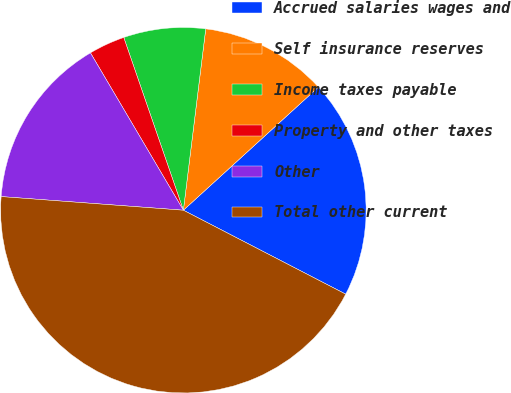<chart> <loc_0><loc_0><loc_500><loc_500><pie_chart><fcel>Accrued salaries wages and<fcel>Self insurance reserves<fcel>Income taxes payable<fcel>Property and other taxes<fcel>Other<fcel>Total other current<nl><fcel>19.36%<fcel>11.28%<fcel>7.24%<fcel>3.2%<fcel>15.32%<fcel>43.59%<nl></chart> 